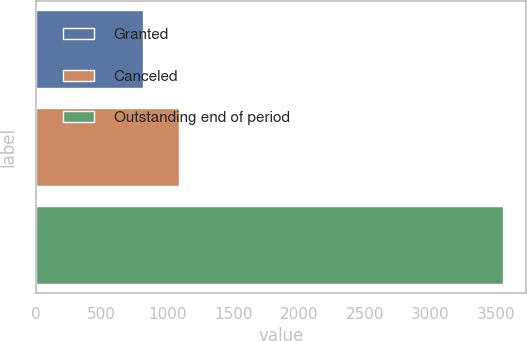Convert chart. <chart><loc_0><loc_0><loc_500><loc_500><bar_chart><fcel>Granted<fcel>Canceled<fcel>Outstanding end of period<nl><fcel>813<fcel>1086.9<fcel>3552<nl></chart> 